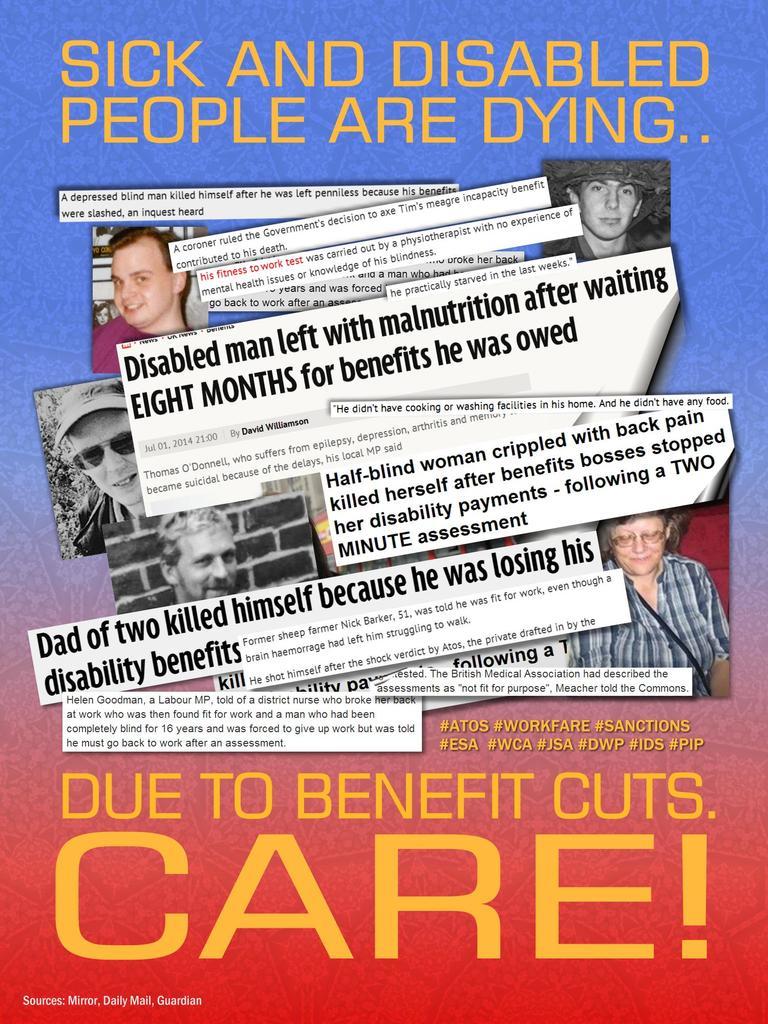Why are people dying?
Your answer should be very brief. Benefit cuts. 